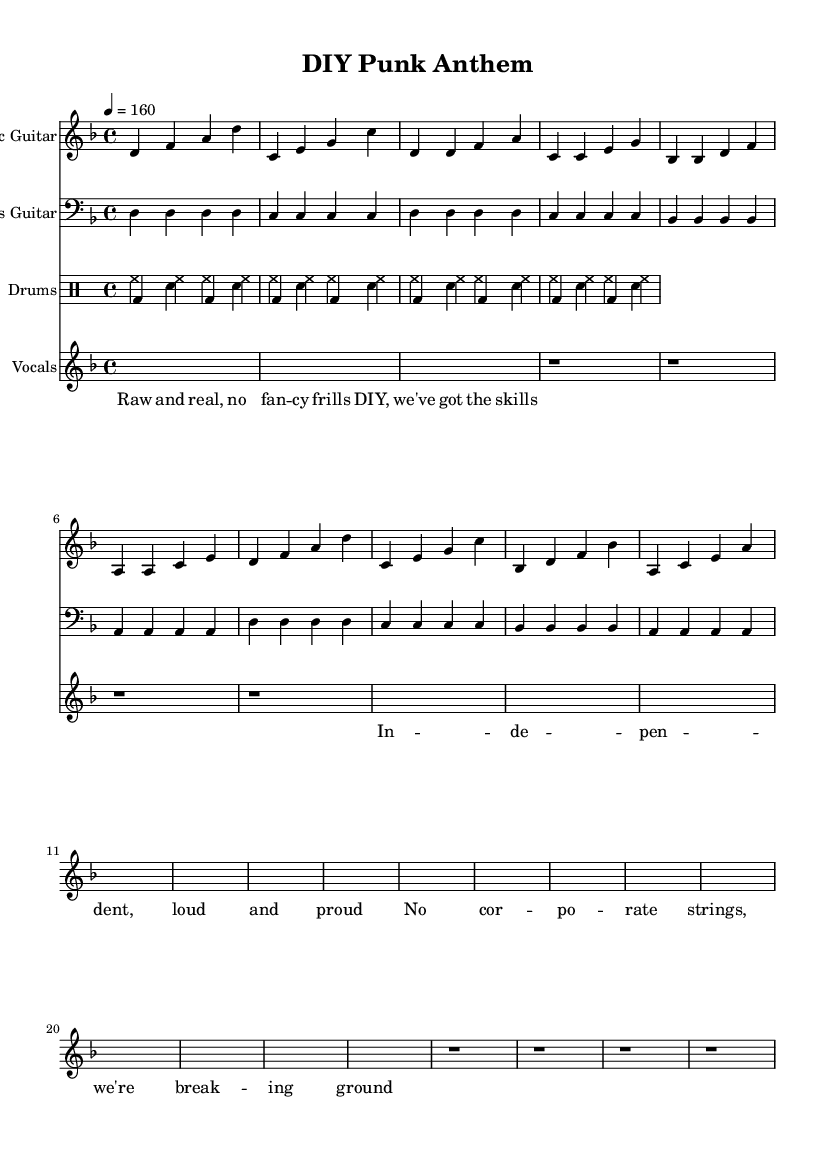What is the key signature of this music? The key signature is D minor, which contains one flat (B flat). This can be determined by looking at the key signature marked at the beginning of the staff.
Answer: D minor What is the time signature of this piece? The time signature is 4/4, which indicates four beats per measure and the quarter note gets one beat. It's shown at the beginning of the score next to the key signature.
Answer: 4/4 What is the tempo marking for this music? The tempo marking indicates 160 beats per minute, as seen in the marking "4 = 160" at the beginning of the piece. This means the quarter note is played at 160 beats per minute.
Answer: 160 How many measures are in the chorus section? There are four measures in the chorus section, which can be counted from the corresponding section of the vocal staff. Each chorus line has one measure, and there are four lines.
Answer: 4 What instruments are included in this score? The instruments included are Electric Guitar, Bass Guitar, Drums, and Vocals. This can be identified by the separate staves for each instrument at the beginning of the score.
Answer: Electric Guitar, Bass Guitar, Drums, Vocals What type of lyrics do the vocals reflect in this music? The lyrics reflect a DIY ethos and independence, highlighting the punk aesthetic of authenticity and self-sufficiency. This understanding comes from analyzing the content of the lyrics written above the vocal staff.
Answer: DIY ethos 